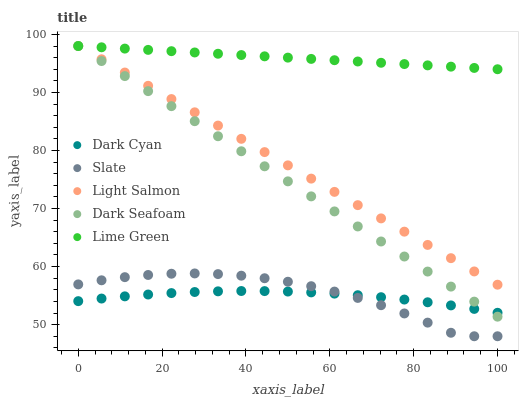Does Dark Cyan have the minimum area under the curve?
Answer yes or no. Yes. Does Lime Green have the maximum area under the curve?
Answer yes or no. Yes. Does Slate have the minimum area under the curve?
Answer yes or no. No. Does Slate have the maximum area under the curve?
Answer yes or no. No. Is Lime Green the smoothest?
Answer yes or no. Yes. Is Slate the roughest?
Answer yes or no. Yes. Is Slate the smoothest?
Answer yes or no. No. Is Lime Green the roughest?
Answer yes or no. No. Does Slate have the lowest value?
Answer yes or no. Yes. Does Lime Green have the lowest value?
Answer yes or no. No. Does Dark Seafoam have the highest value?
Answer yes or no. Yes. Does Slate have the highest value?
Answer yes or no. No. Is Dark Cyan less than Lime Green?
Answer yes or no. Yes. Is Dark Seafoam greater than Slate?
Answer yes or no. Yes. Does Light Salmon intersect Dark Seafoam?
Answer yes or no. Yes. Is Light Salmon less than Dark Seafoam?
Answer yes or no. No. Is Light Salmon greater than Dark Seafoam?
Answer yes or no. No. Does Dark Cyan intersect Lime Green?
Answer yes or no. No. 